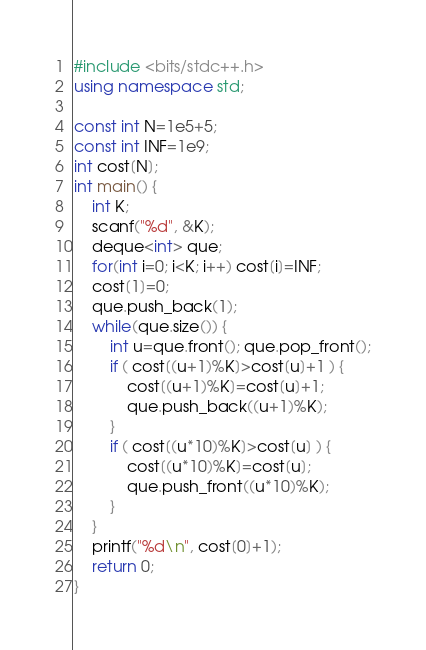<code> <loc_0><loc_0><loc_500><loc_500><_C++_>#include <bits/stdc++.h>
using namespace std;

const int N=1e5+5;
const int INF=1e9;
int cost[N];
int main() {
	int K;
	scanf("%d", &K);
	deque<int> que;
	for(int i=0; i<K; i++) cost[i]=INF;
	cost[1]=0;
	que.push_back(1);
	while(que.size()) {
		int u=que.front(); que.pop_front();
		if ( cost[(u+1)%K]>cost[u]+1 ) {
			cost[(u+1)%K]=cost[u]+1;
			que.push_back((u+1)%K);
		}
		if ( cost[(u*10)%K]>cost[u] ) {
			cost[(u*10)%K]=cost[u];
			que.push_front((u*10)%K);
		}
	}
	printf("%d\n", cost[0]+1);
	return 0;
}</code> 